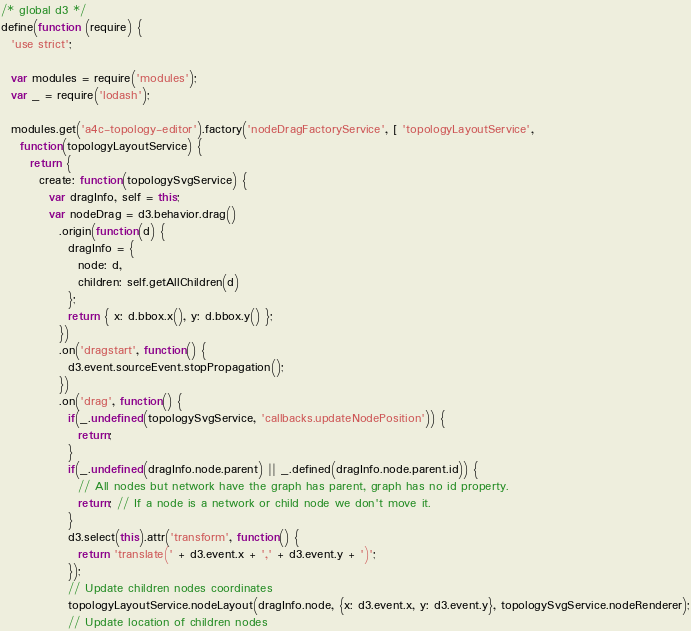<code> <loc_0><loc_0><loc_500><loc_500><_JavaScript_>/* global d3 */
define(function (require) {
  'use strict';

  var modules = require('modules');
  var _ = require('lodash');

  modules.get('a4c-topology-editor').factory('nodeDragFactoryService', [ 'topologyLayoutService',
    function(topologyLayoutService) {
      return {
        create: function(topologySvgService) {
          var dragInfo, self = this;
          var nodeDrag = d3.behavior.drag()
            .origin(function(d) {
              dragInfo = {
                node: d,
                children: self.getAllChildren(d)
              };
              return { x: d.bbox.x(), y: d.bbox.y() };
            })
            .on('dragstart', function() {
              d3.event.sourceEvent.stopPropagation();
            })
            .on('drag', function() {
              if(_.undefined(topologySvgService, 'callbacks.updateNodePosition')) {
                return;
              }
              if(_.undefined(dragInfo.node.parent) || _.defined(dragInfo.node.parent.id)) {
                // All nodes but network have the graph has parent, graph has no id property.
                return; // If a node is a network or child node we don't move it.
              }
              d3.select(this).attr('transform', function() {
                return 'translate(' + d3.event.x + ',' + d3.event.y + ')';
              });
              // Update children nodes coordinates
              topologyLayoutService.nodeLayout(dragInfo.node, {x: d3.event.x, y: d3.event.y}, topologySvgService.nodeRenderer);
              // Update location of children nodes</code> 